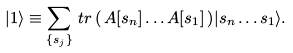<formula> <loc_0><loc_0><loc_500><loc_500>| 1 \rangle \equiv \sum _ { \{ s _ { j } \} } { \, t r \left ( \, A [ s _ { n } ] \dots A [ s _ { 1 } ] \, \right ) } | s _ { n } \dots s _ { 1 } \rangle .</formula> 